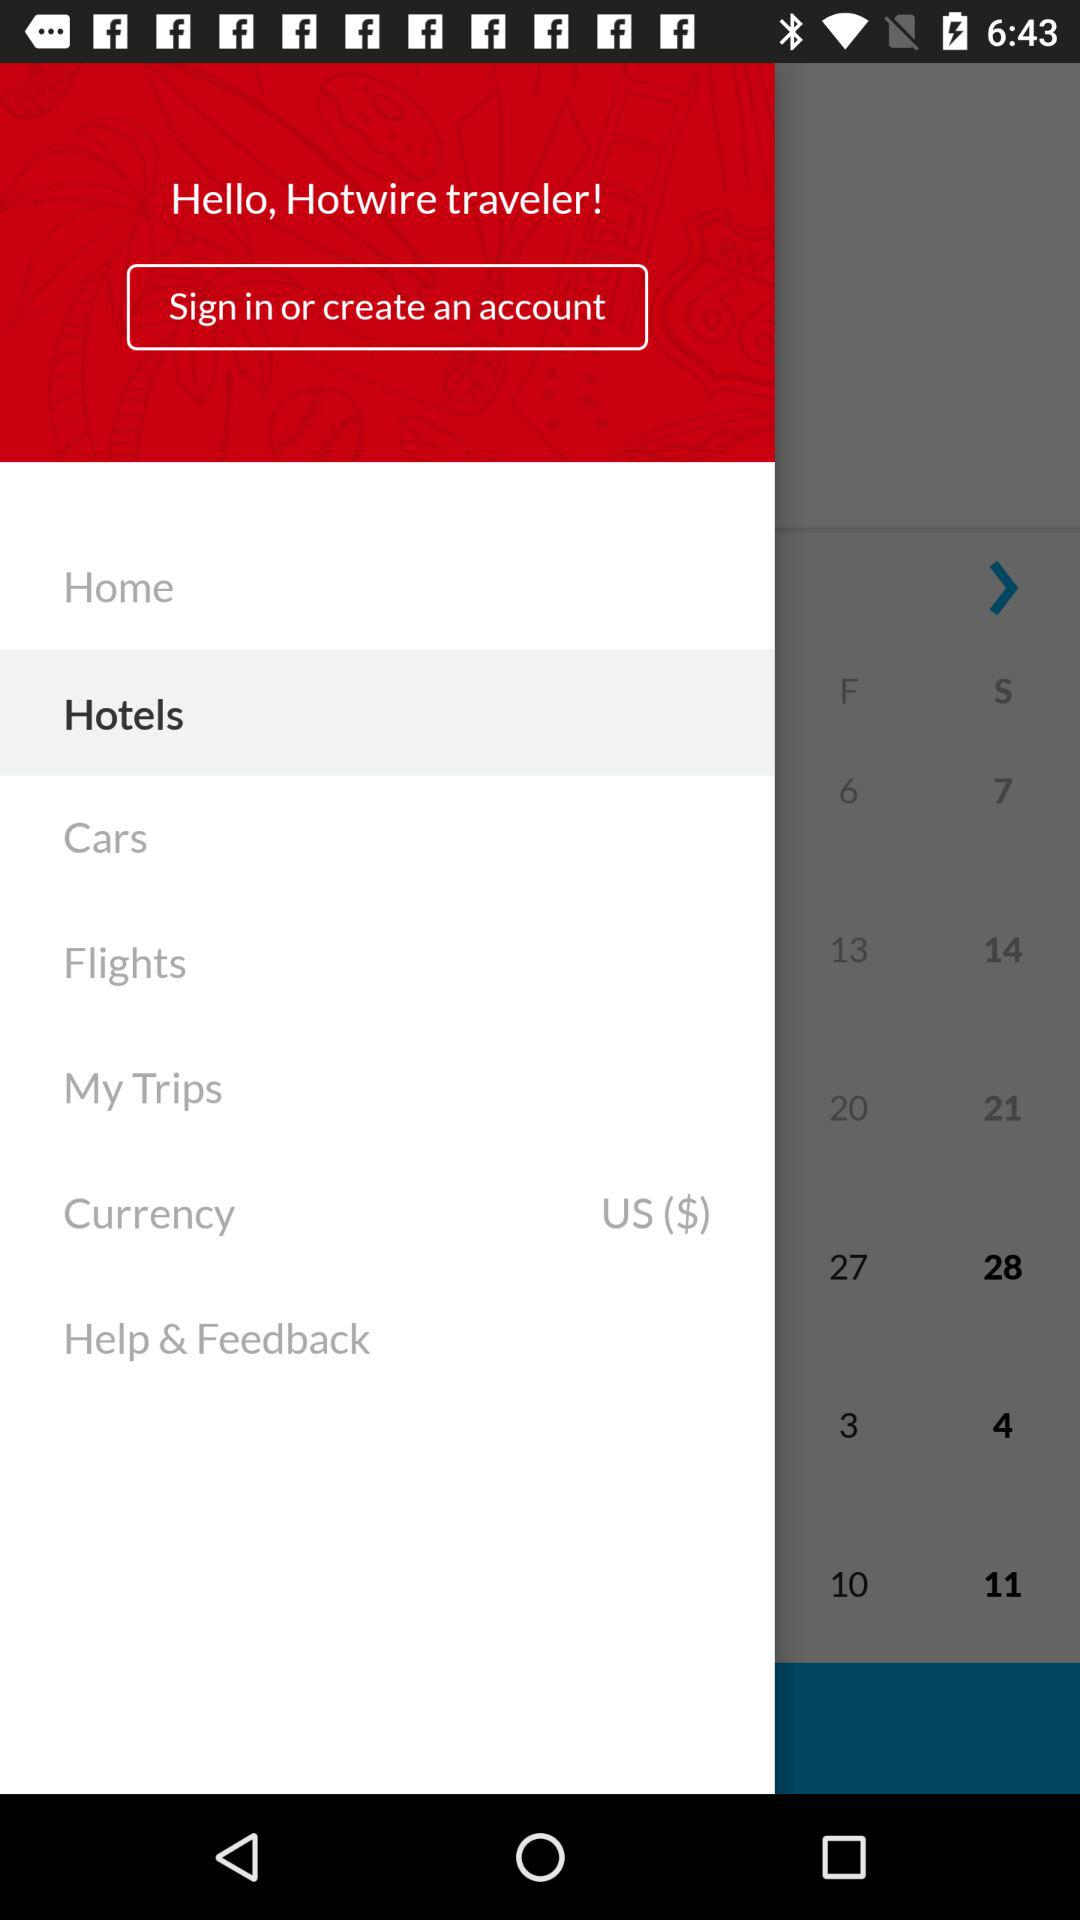What is the app name? The app name is "Hotwire". 